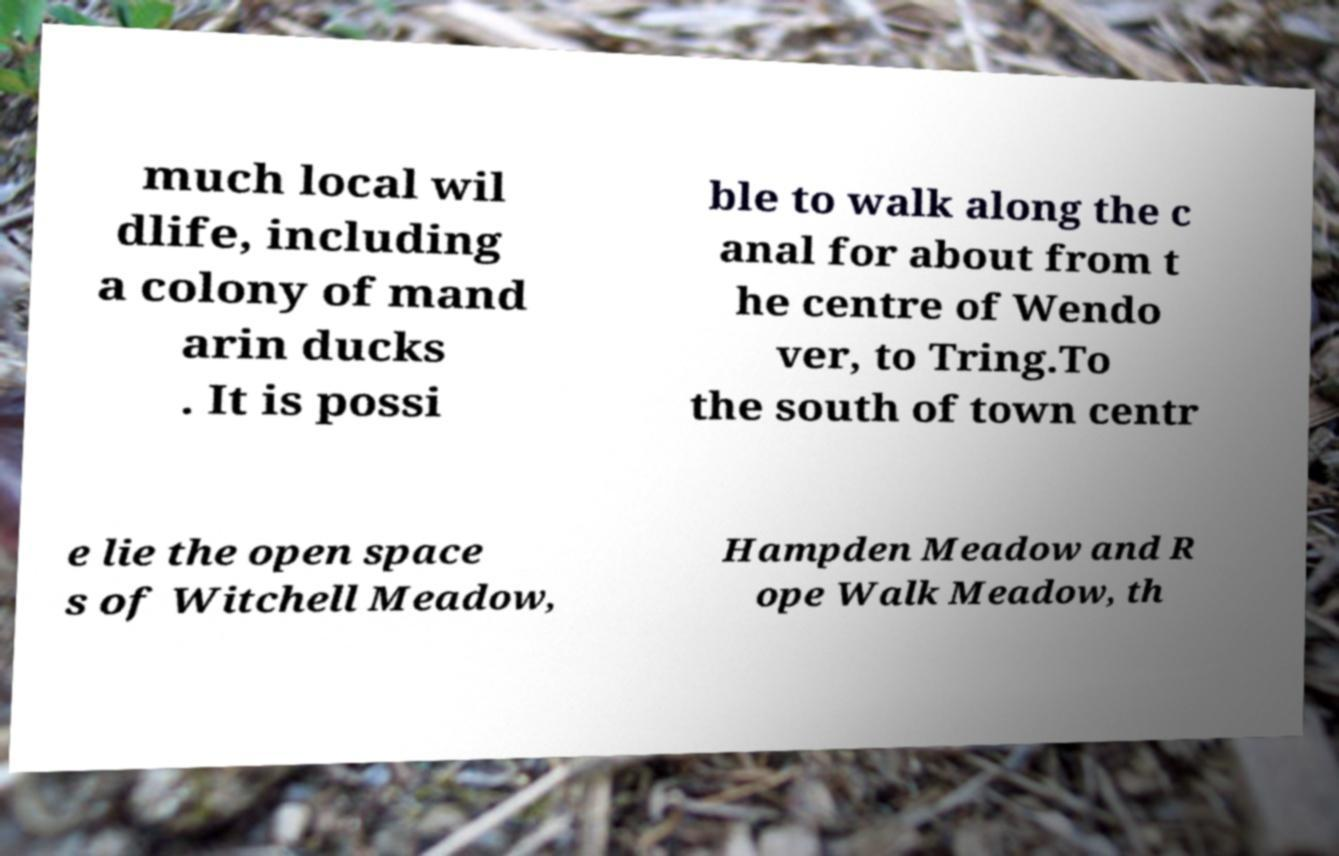I need the written content from this picture converted into text. Can you do that? much local wil dlife, including a colony of mand arin ducks . It is possi ble to walk along the c anal for about from t he centre of Wendo ver, to Tring.To the south of town centr e lie the open space s of Witchell Meadow, Hampden Meadow and R ope Walk Meadow, th 